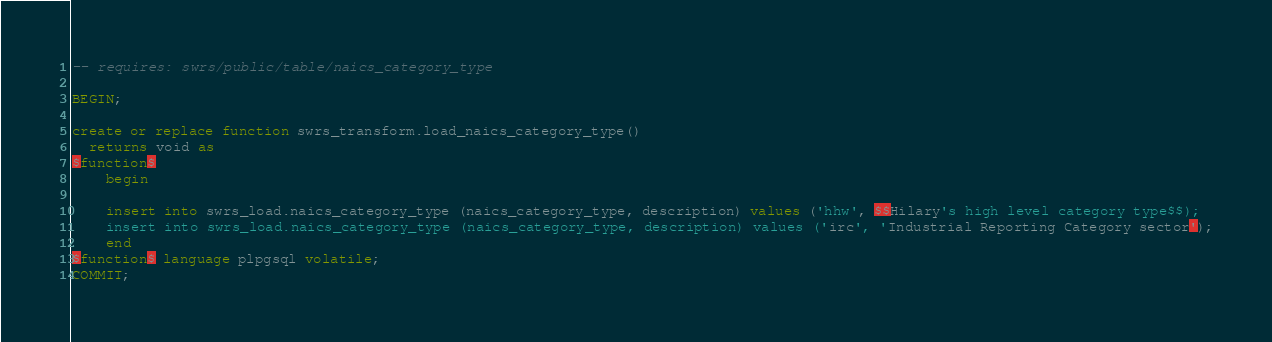<code> <loc_0><loc_0><loc_500><loc_500><_SQL_>-- requires: swrs/public/table/naics_category_type

BEGIN;

create or replace function swrs_transform.load_naics_category_type()
  returns void as
$function$
    begin

    insert into swrs_load.naics_category_type (naics_category_type, description) values ('hhw', $$Hilary's high level category type$$);
    insert into swrs_load.naics_category_type (naics_category_type, description) values ('irc', 'Industrial Reporting Category sector');
    end
$function$ language plpgsql volatile;
COMMIT;
</code> 